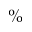Convert formula to latex. <formula><loc_0><loc_0><loc_500><loc_500>\%</formula> 